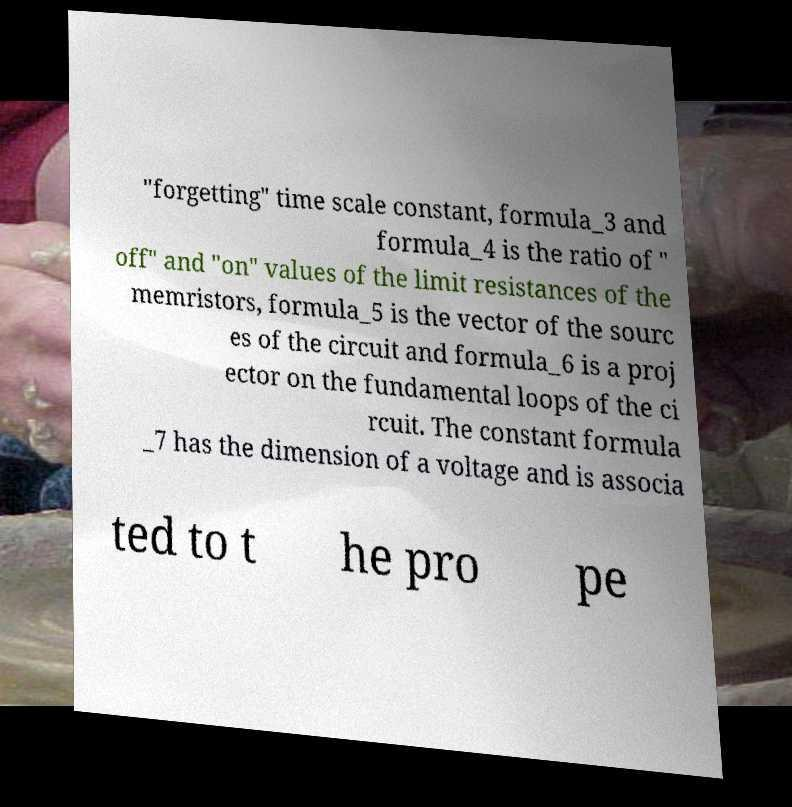Could you assist in decoding the text presented in this image and type it out clearly? "forgetting" time scale constant, formula_3 and formula_4 is the ratio of " off" and "on" values of the limit resistances of the memristors, formula_5 is the vector of the sourc es of the circuit and formula_6 is a proj ector on the fundamental loops of the ci rcuit. The constant formula _7 has the dimension of a voltage and is associa ted to t he pro pe 